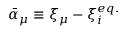<formula> <loc_0><loc_0><loc_500><loc_500>{ \bar { \alpha } } _ { \mu } \equiv \xi _ { \mu } - \xi _ { i } ^ { e q . }</formula> 